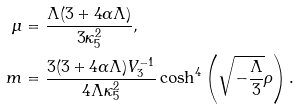Convert formula to latex. <formula><loc_0><loc_0><loc_500><loc_500>\mu & = \frac { \Lambda ( 3 + 4 \alpha \Lambda ) } { 3 \kappa _ { 5 } ^ { 2 } } , \\ m & = \frac { 3 ( 3 + 4 \alpha \Lambda ) V _ { 3 } ^ { - 1 } } { 4 \Lambda \kappa _ { 5 } ^ { 2 } } \cosh ^ { 4 } \left ( \sqrt { - \frac { \Lambda } { 3 } } \rho \right ) .</formula> 